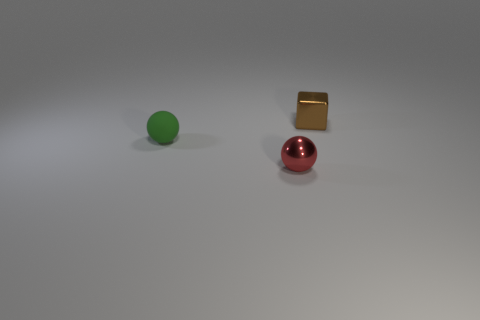Is the number of spheres behind the brown cube less than the number of big green metallic spheres?
Make the answer very short. No. Are there any small rubber things on the right side of the small red thing?
Provide a succinct answer. No. Is there a red object that has the same shape as the small green thing?
Make the answer very short. Yes. What shape is the red thing that is the same size as the green ball?
Offer a very short reply. Sphere. What number of objects are small spheres that are to the left of the red shiny thing or tiny rubber balls?
Give a very brief answer. 1. Is there another green sphere of the same size as the metallic sphere?
Provide a succinct answer. Yes. There is a object that is in front of the green rubber sphere; does it have the same size as the tiny rubber thing?
Ensure brevity in your answer.  Yes. The shiny sphere is what size?
Your response must be concise. Small. What color is the thing in front of the thing left of the metal object on the left side of the cube?
Your answer should be compact. Red. There is a tiny thing that is to the left of the red shiny ball; does it have the same color as the tiny metal ball?
Your answer should be compact. No. 